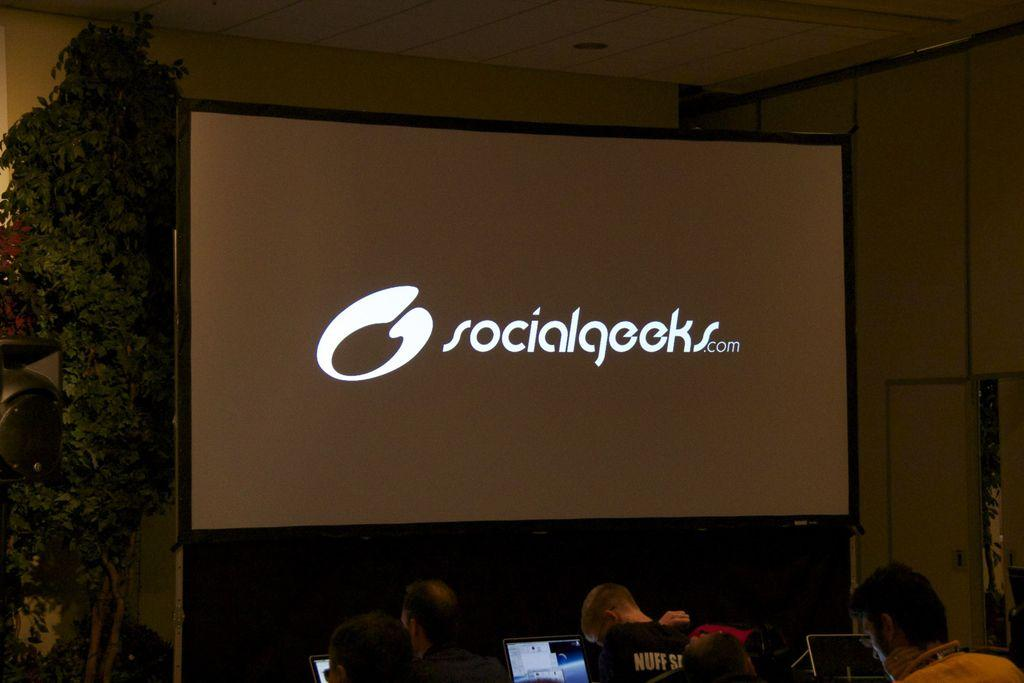Who or what is present in the image? There are people in the image. What electronic devices can be seen in the image? There are laptops in the image. What type of natural elements are visible in the image? There are trees in the image. What else can be seen in the image besides people, laptops, and trees? There are other objects in the image. Is there any written or printed text visible in the image? Yes, there is text visible in the image. What is displayed on the screens of the laptops in the image? There are items on a screen in the image. What type of creature can be seen interacting with the people in the image? There is no creature present in the image; it only features people, laptops, trees, other objects, text, and items on a screen. 